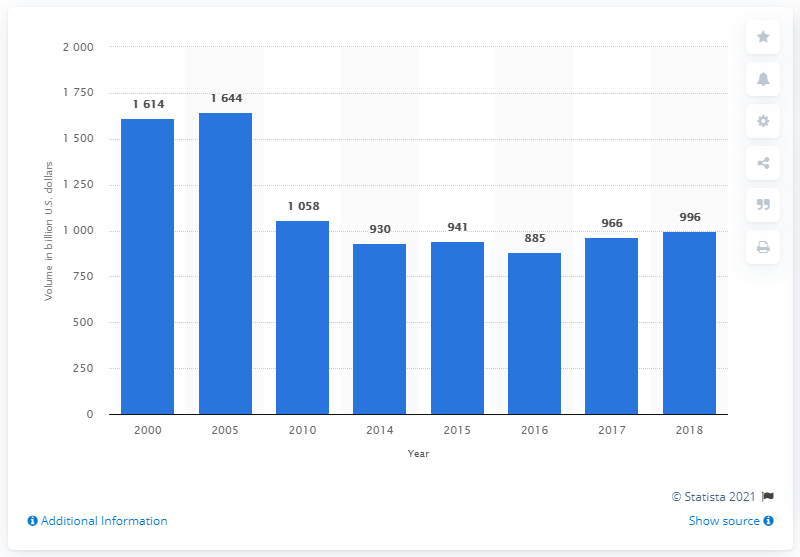List a handful of essential elements in this visual. As of 2016, the sum total of the highest two outstanding volumes of money market instruments in the United States was approximately 3,258 billion U.S. dollars. According to the U.S. in the year 2016, the volume of outstanding money market instruments was approximately 885 billion U.S. dollars. The amount of money market instruments outstanding in the United States in 2018 was approximately $996 billion. 